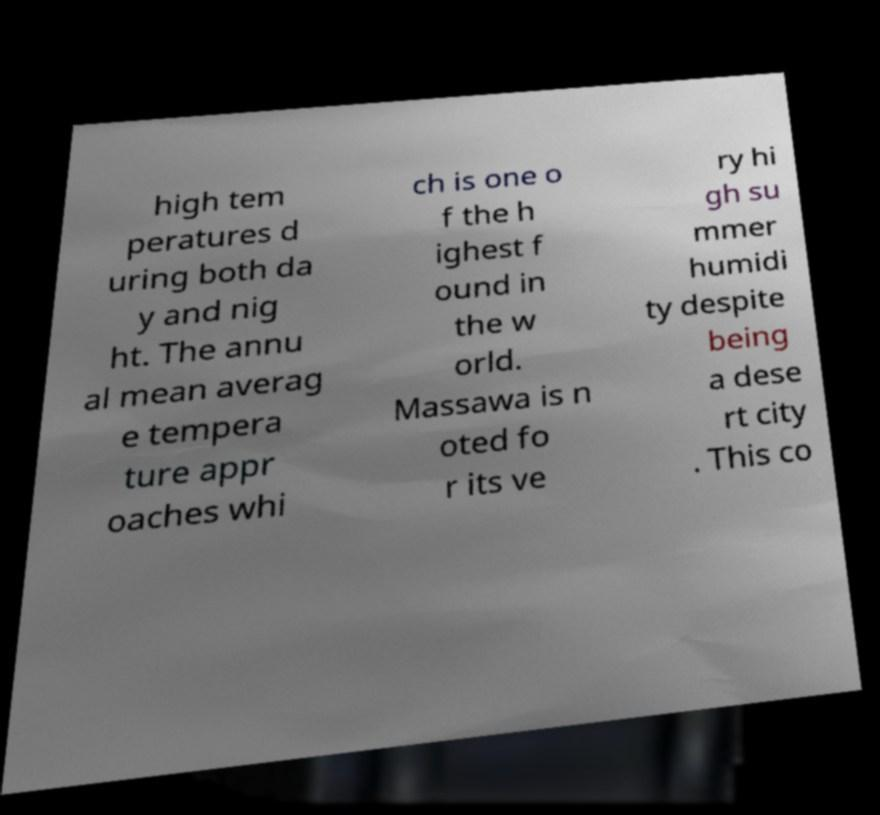Can you read and provide the text displayed in the image?This photo seems to have some interesting text. Can you extract and type it out for me? high tem peratures d uring both da y and nig ht. The annu al mean averag e tempera ture appr oaches whi ch is one o f the h ighest f ound in the w orld. Massawa is n oted fo r its ve ry hi gh su mmer humidi ty despite being a dese rt city . This co 